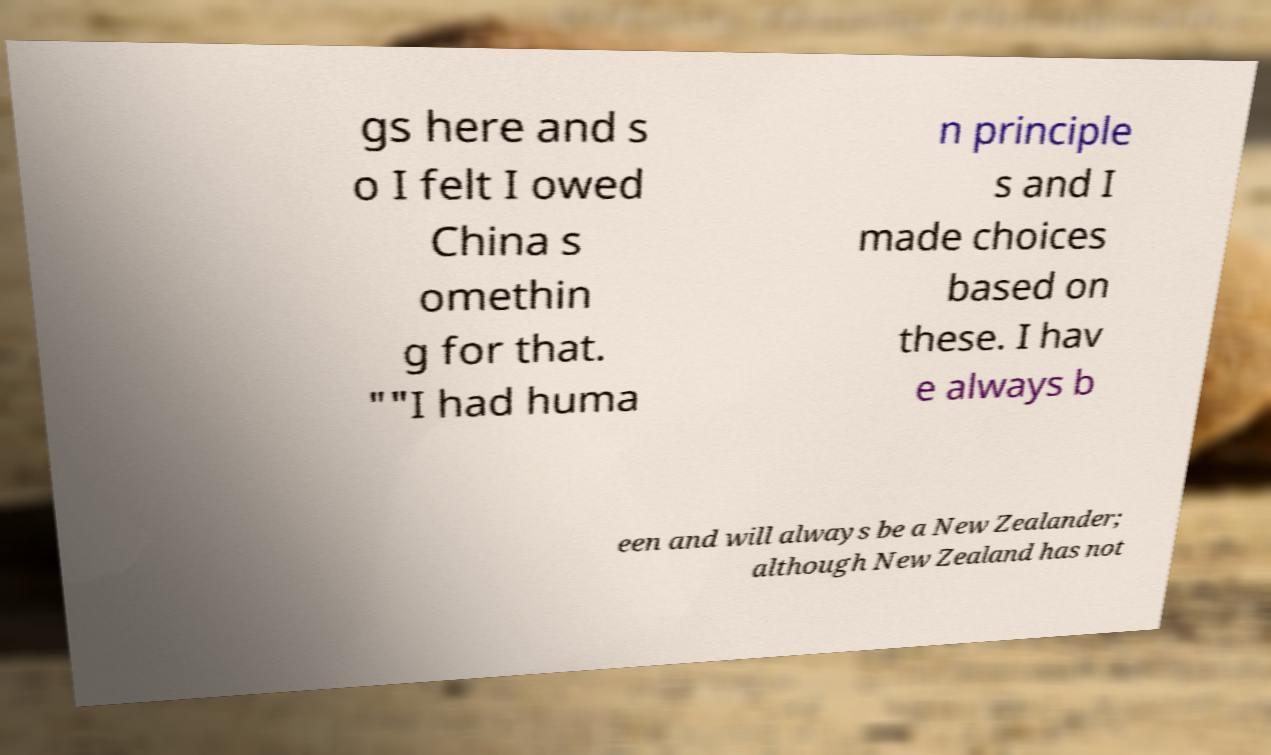I need the written content from this picture converted into text. Can you do that? gs here and s o I felt I owed China s omethin g for that. ""I had huma n principle s and I made choices based on these. I hav e always b een and will always be a New Zealander; although New Zealand has not 